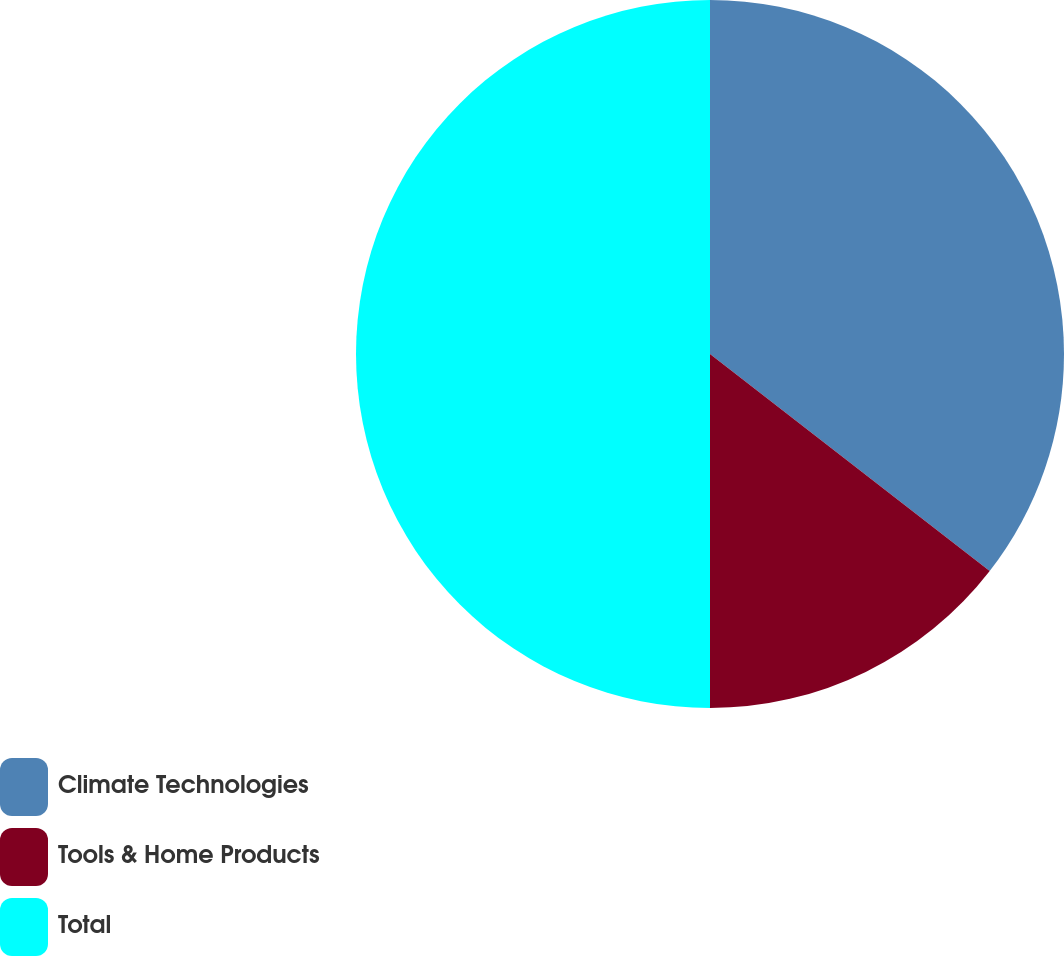<chart> <loc_0><loc_0><loc_500><loc_500><pie_chart><fcel>Climate Technologies<fcel>Tools & Home Products<fcel>Total<nl><fcel>35.5%<fcel>14.5%<fcel>50.0%<nl></chart> 